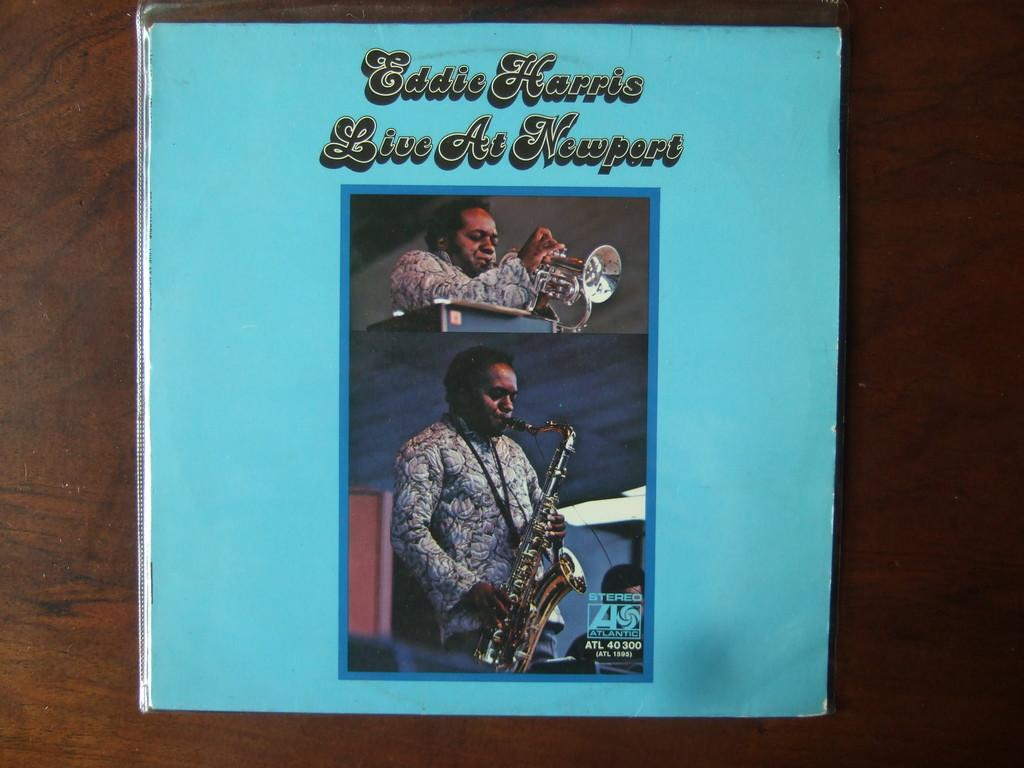<image>
Share a concise interpretation of the image provided. Blue album cover that says "Eddie Harris" on the cover. 